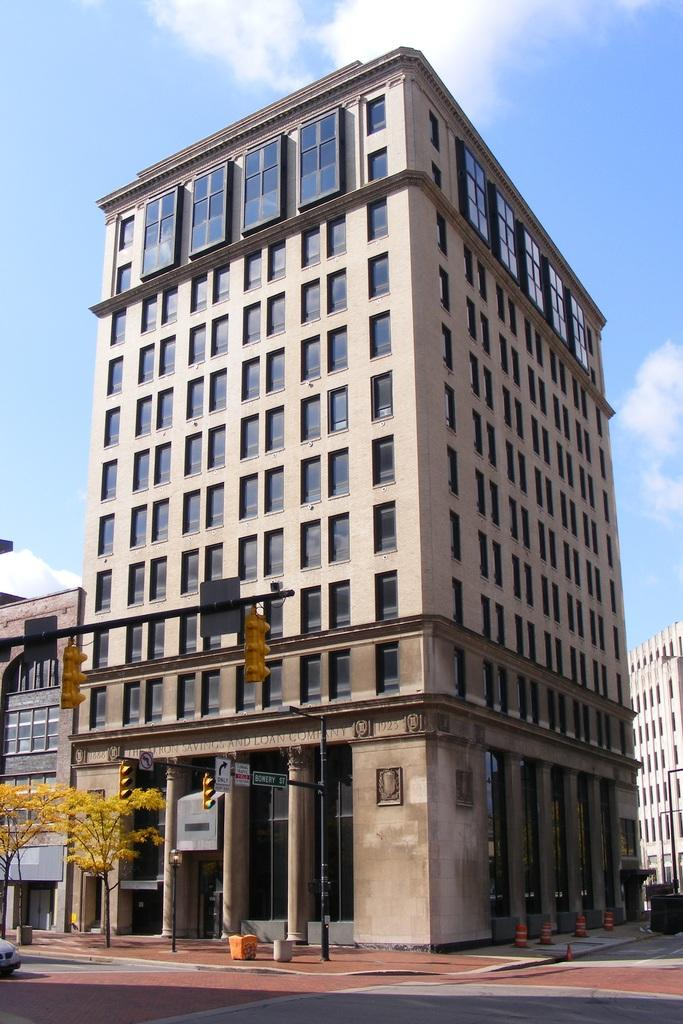What is the main structure in the image? There is a building in the image. What feature can be seen on the building? The building has windows. What color is the sky in the image? The sky is blue in color. Can you see any wounds on the building in the image? There are no wounds present on the building in the image. Is there a mask covering the building in the image? There is no mask covering the building in the image. 